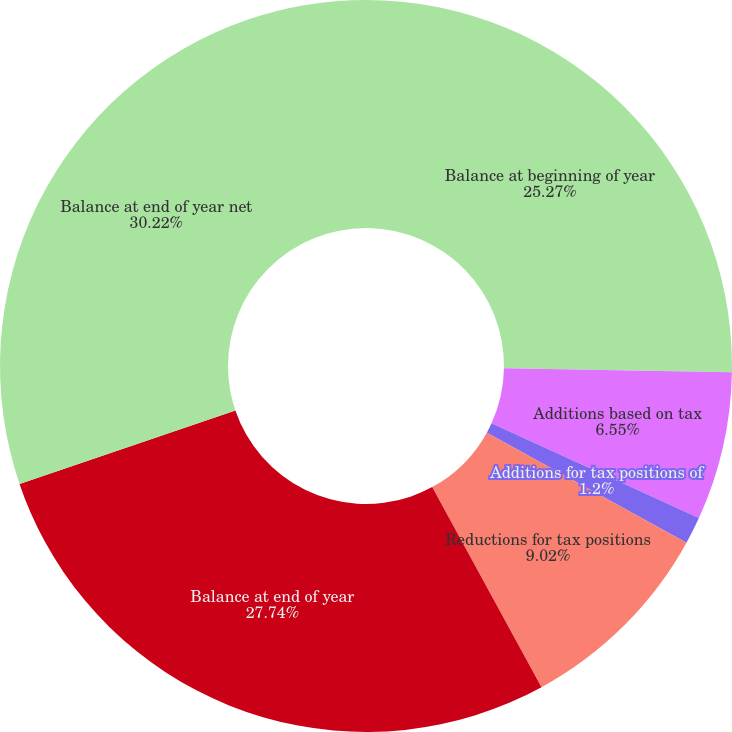Convert chart. <chart><loc_0><loc_0><loc_500><loc_500><pie_chart><fcel>Balance at beginning of year<fcel>Additions based on tax<fcel>Additions for tax positions of<fcel>Reductions for tax positions<fcel>Balance at end of year<fcel>Balance at end of year net<nl><fcel>25.27%<fcel>6.55%<fcel>1.2%<fcel>9.02%<fcel>27.74%<fcel>30.22%<nl></chart> 